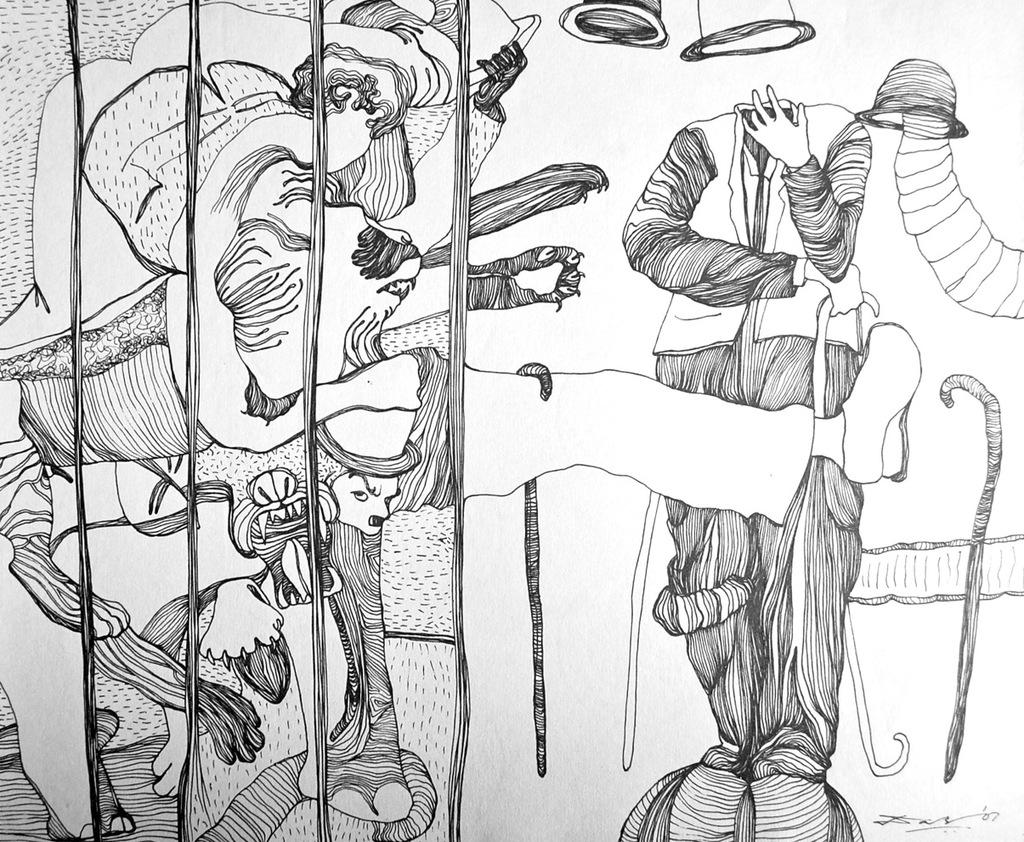What is the main subject of the image? The image contains a sketch. What can be seen in the sketch? The sketch depicts different structures. What is the name of the fear depicted in the sketch? There is no fear depicted in the sketch, as it only contains different structures. 